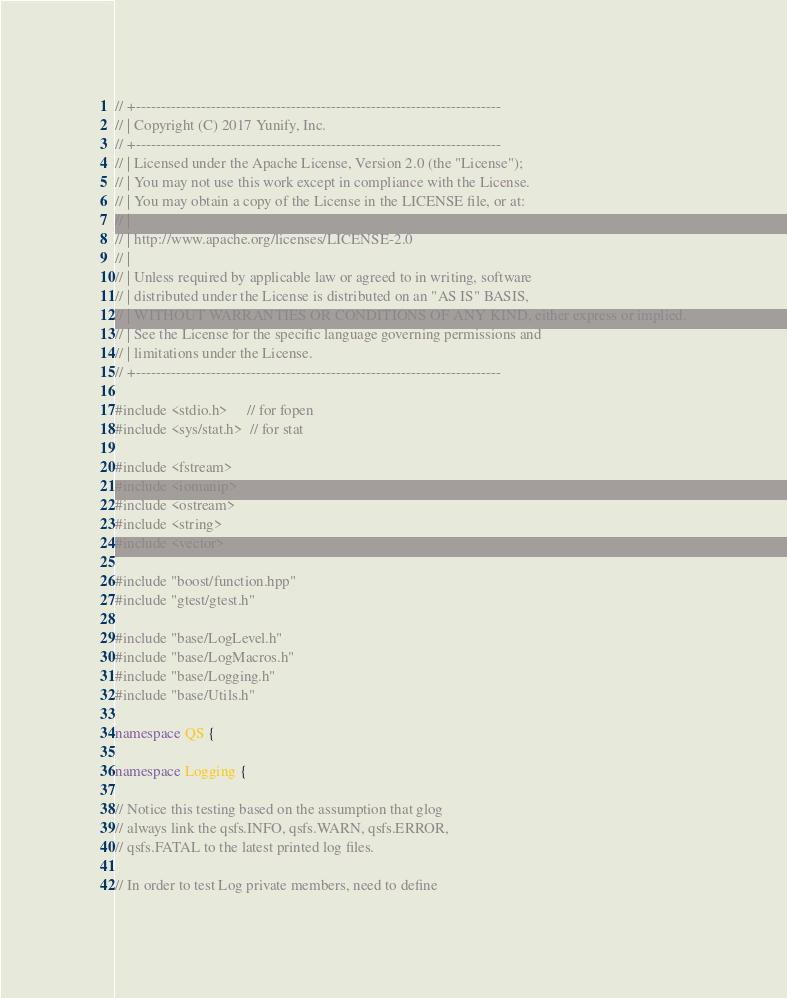Convert code to text. <code><loc_0><loc_0><loc_500><loc_500><_C++_>// +-------------------------------------------------------------------------
// | Copyright (C) 2017 Yunify, Inc.
// +-------------------------------------------------------------------------
// | Licensed under the Apache License, Version 2.0 (the "License");
// | You may not use this work except in compliance with the License.
// | You may obtain a copy of the License in the LICENSE file, or at:
// |
// | http://www.apache.org/licenses/LICENSE-2.0
// |
// | Unless required by applicable law or agreed to in writing, software
// | distributed under the License is distributed on an "AS IS" BASIS,
// | WITHOUT WARRANTIES OR CONDITIONS OF ANY KIND, either express or implied.
// | See the License for the specific language governing permissions and
// | limitations under the License.
// +-------------------------------------------------------------------------

#include <stdio.h>     // for fopen
#include <sys/stat.h>  // for stat

#include <fstream>
#include <iomanip>
#include <ostream>
#include <string>
#include <vector>

#include "boost/function.hpp"
#include "gtest/gtest.h"

#include "base/LogLevel.h"
#include "base/LogMacros.h"
#include "base/Logging.h"
#include "base/Utils.h"

namespace QS {

namespace Logging {

// Notice this testing based on the assumption that glog
// always link the qsfs.INFO, qsfs.WARN, qsfs.ERROR,
// qsfs.FATAL to the latest printed log files.

// In order to test Log private members, need to define</code> 